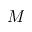Convert formula to latex. <formula><loc_0><loc_0><loc_500><loc_500>M</formula> 